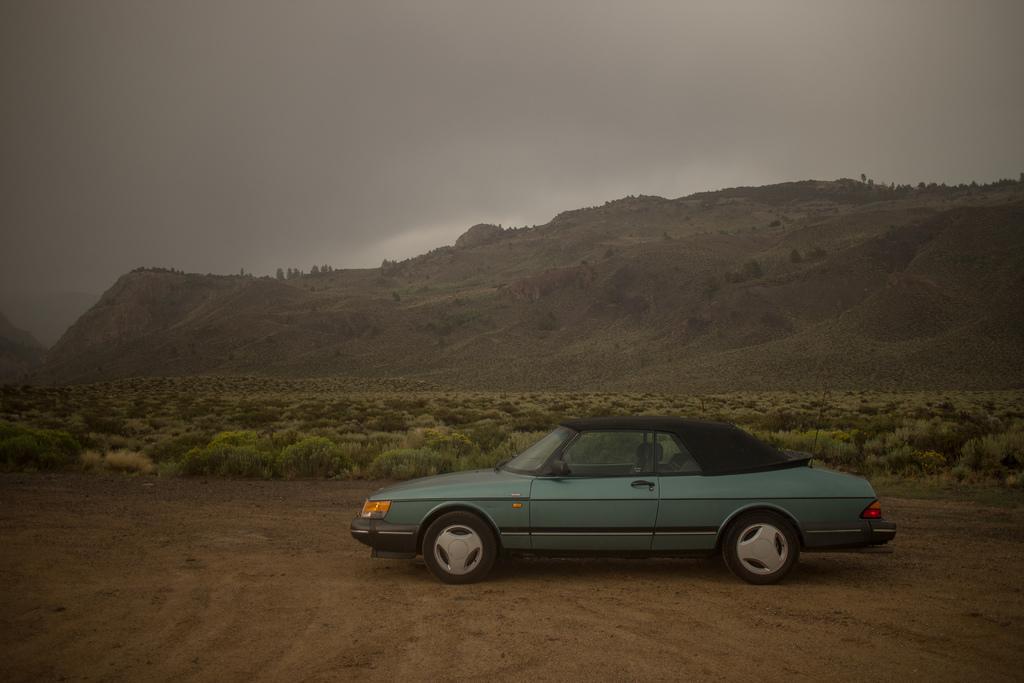Please provide a concise description of this image. Front of the image we can see a car. Background there is a mountain, trees, plants and sky. 